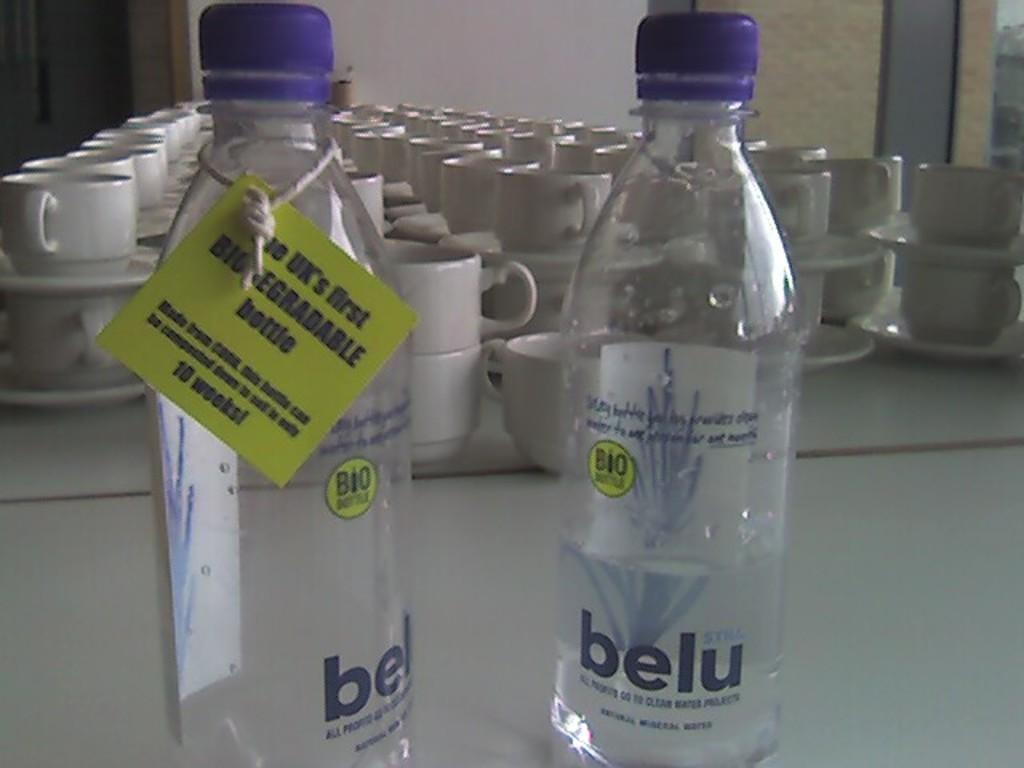<image>
Create a compact narrative representing the image presented. Two bottles of belu water and several mug and saucer sets behind them. 